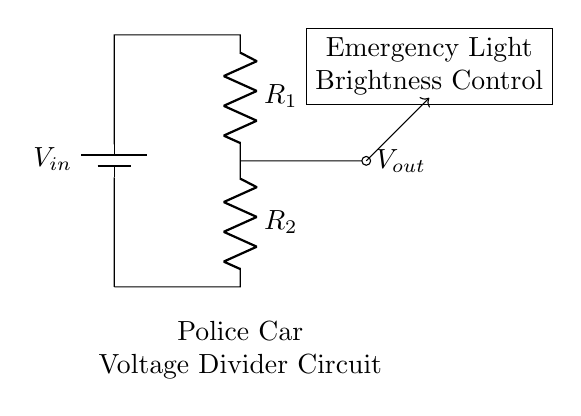What is the purpose of this circuit? The circuit is designed to adjust the brightness of emergency lights in a police car by using a voltage divider to control the output voltage across the light.
Answer: Brightness control What components are present in this circuit? The circuit contains two resistors (R1 and R2) and a voltage source (Vin) to create the voltage divider.
Answer: Two resistors and a voltage source What is the output voltage related to? The output voltage (Vout) corresponds to the voltage drop across resistor R2 in the voltage divider configuration, which governs the brightness of the emergency lights.
Answer: Brightness of emergency lights How is the voltage divider configured? The voltage divider consists of two resistors, R1 and R2, connected in series between the input voltage source and ground, with the output taken from the junction of the resistors.
Answer: Series connection of R1 and R2 What would happen if R1's value is increased? Increasing R1 would result in a higher output voltage (Vout), which would make the emergency lights brighter, as Vout is a fraction of Vin based on the values of R1 and R2.
Answer: Emergency lights would get brighter Which component primarily controls the brightness? Resistor R2 primarily controls the brightness because the output voltage (Vout) is determined by the voltage drop across it.
Answer: Resistor R2 